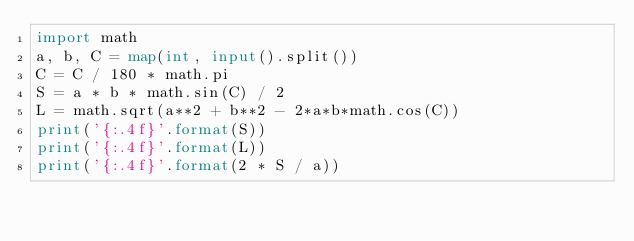<code> <loc_0><loc_0><loc_500><loc_500><_Python_>import math
a, b, C = map(int, input().split())
C = C / 180 * math.pi
S = a * b * math.sin(C) / 2
L = math.sqrt(a**2 + b**2 - 2*a*b*math.cos(C))
print('{:.4f}'.format(S))
print('{:.4f}'.format(L))
print('{:.4f}'.format(2 * S / a))</code> 